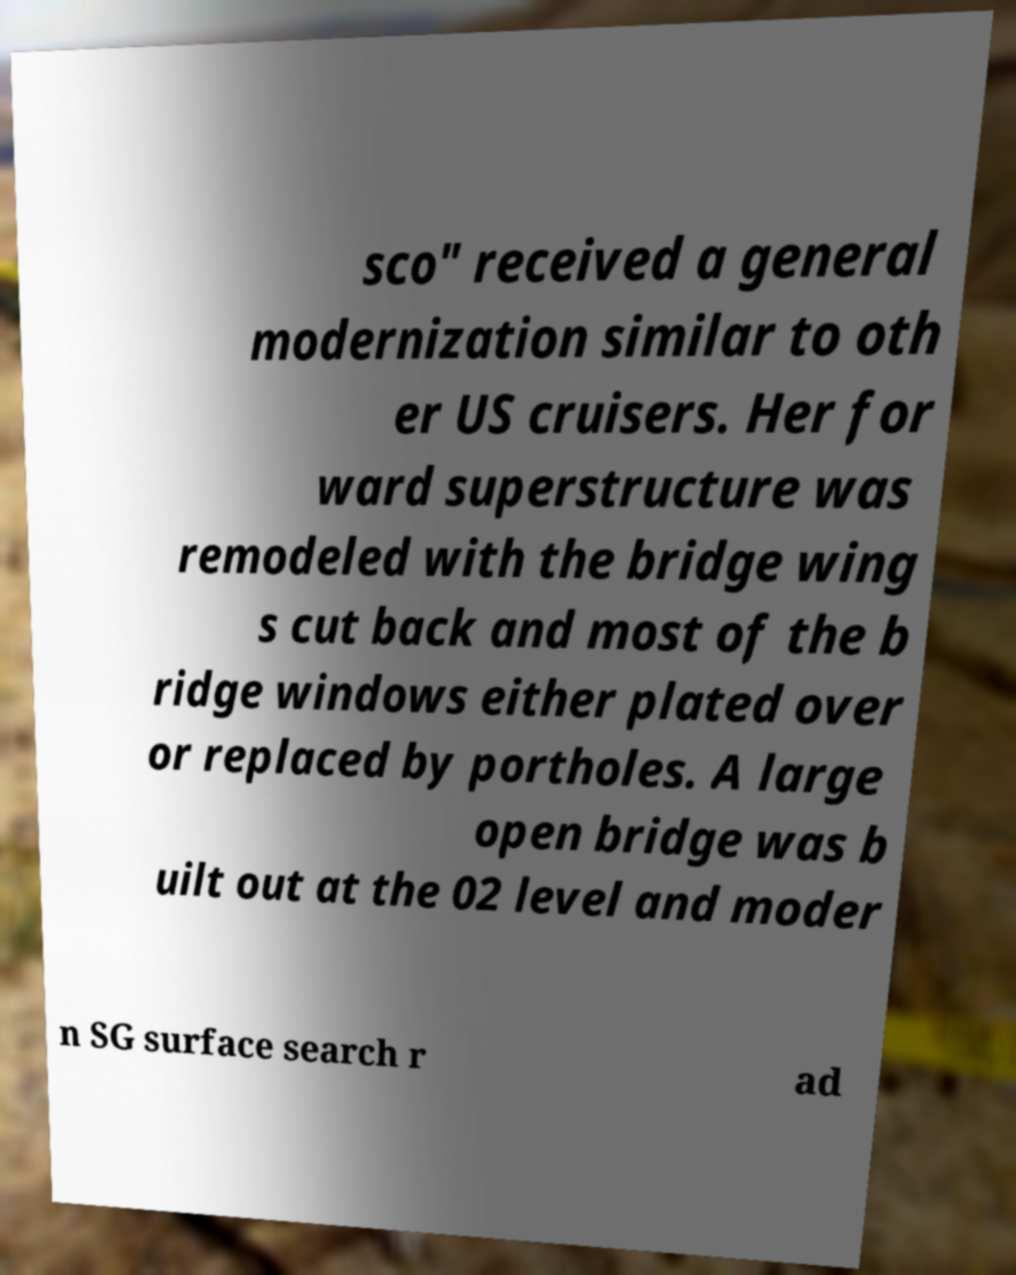Could you extract and type out the text from this image? sco" received a general modernization similar to oth er US cruisers. Her for ward superstructure was remodeled with the bridge wing s cut back and most of the b ridge windows either plated over or replaced by portholes. A large open bridge was b uilt out at the 02 level and moder n SG surface search r ad 